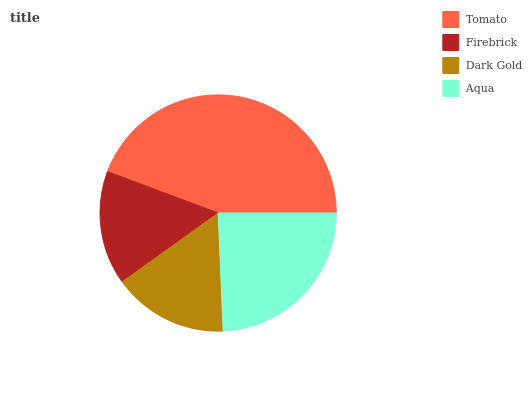Is Firebrick the minimum?
Answer yes or no. Yes. Is Tomato the maximum?
Answer yes or no. Yes. Is Dark Gold the minimum?
Answer yes or no. No. Is Dark Gold the maximum?
Answer yes or no. No. Is Dark Gold greater than Firebrick?
Answer yes or no. Yes. Is Firebrick less than Dark Gold?
Answer yes or no. Yes. Is Firebrick greater than Dark Gold?
Answer yes or no. No. Is Dark Gold less than Firebrick?
Answer yes or no. No. Is Aqua the high median?
Answer yes or no. Yes. Is Dark Gold the low median?
Answer yes or no. Yes. Is Firebrick the high median?
Answer yes or no. No. Is Firebrick the low median?
Answer yes or no. No. 